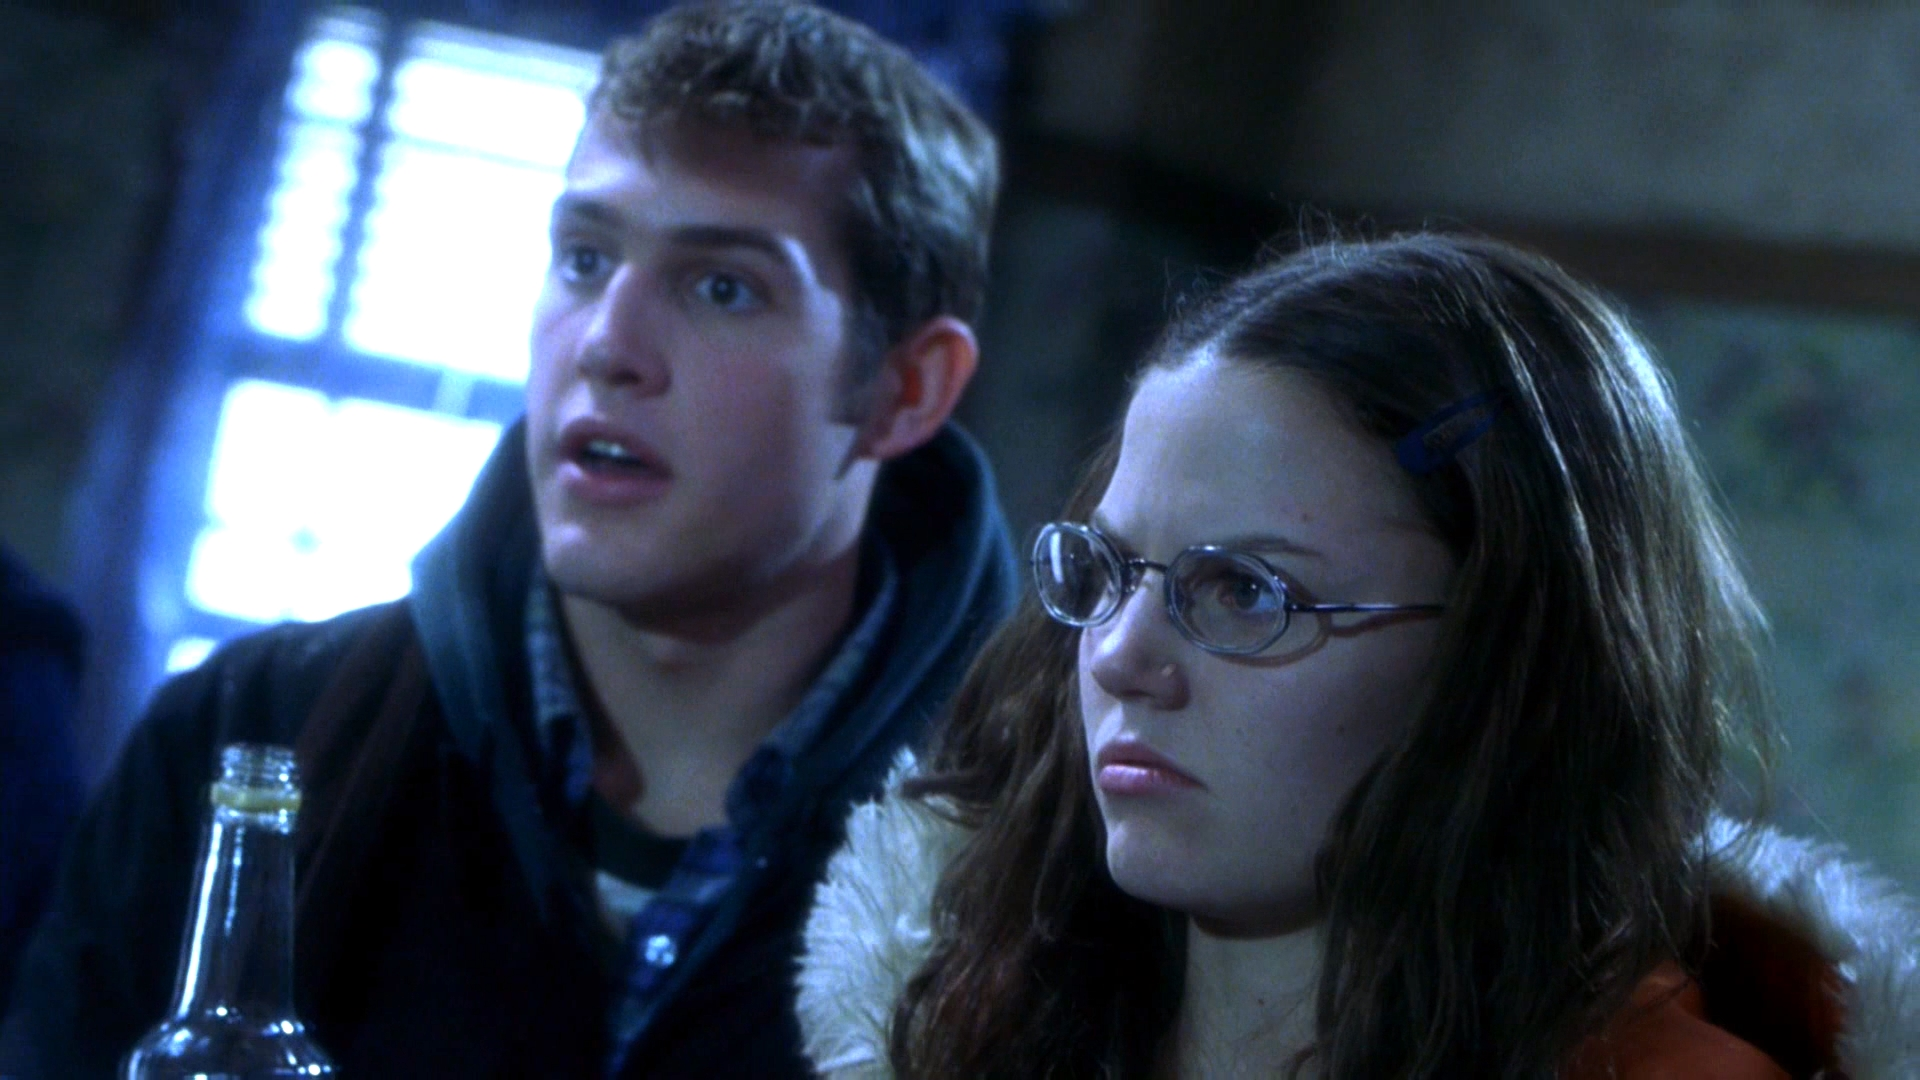Can you describe the setting in which these characters are located? The setting appears to be a semi-industrial location, possibly a laboratory or workshop, indicated by the metal structures and the complex machinery in the background. It suits the theme of a high-stakes work environment where critical tasks or experiments might be conducted, adding a layer of intensity to their shocked reactions. 